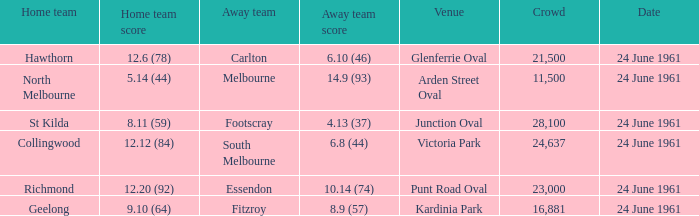What was the home team's score at the game attended by more than 24,637? 8.11 (59). 